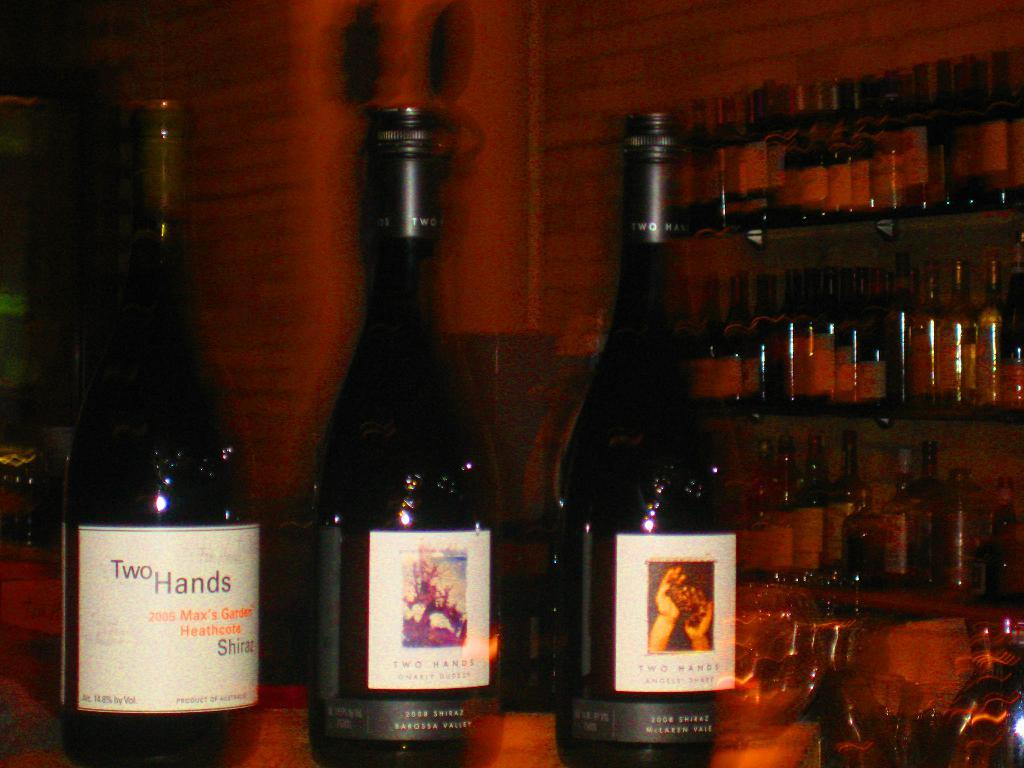<image>
Write a terse but informative summary of the picture. Various bottles of wine on display at a bar including Two Hands from 2005. 